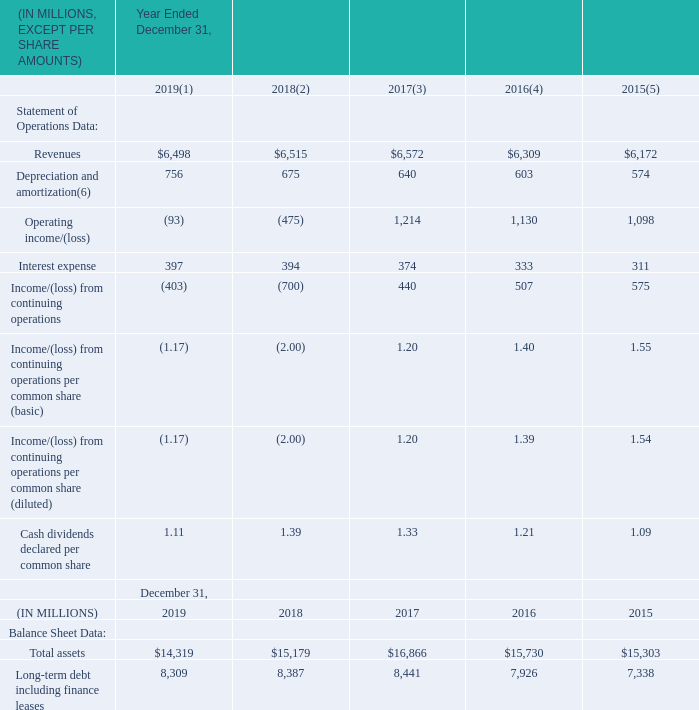Item 6. Selected Financial and Other Data
The following table sets forth selected historical consolidated financial data as of the dates and for the periods indicated. The selected consolidated statement of operations data for the years ended December 31, 2019, 2018 and 2017, and selected consolidated balance sheet data as of December 31, 2019 and 2018 have been derived from our audited consolidated financial statements and related notes appearing elsewhere in this Form 10-K. The selected consolidated statement of operations data for the years ended December 31, 2016 and 2015 and selected consolidated balance sheet data as of December 31, 2017, 2016 and 2015 have been derived from our audited consolidated financial statements, which are not included in this annual report on Form 10-K.
The results of operations for any period are not necessarily indicative of the results to be expected for any future period. The audited consolidated financial statements, from which the historical financial information for the periods set forth below have been derived, were prepared in accordance with U.S. generally accepted accounting principles (“GAAP”). The selected historical consolidated financial data set forth below should be read in conjunction with, and are qualified by reference to “Management’s Discussion and Analysis of Financial Condition and Results of Operations” and our audited consolidated financial statements and related notes thereto appearing elsewhere in this annual report on Form 10-K.
(1) Loss for the year ended December 31, 2019 included $1,004 million in impairment charges associated with our Connect reporting unit, a non-cash expense of $170 for the settlement of certain pension plans and $80 million in restructuring charges. See Item 7. “Management’s Discussion and Analysis of Financial Condition and Results of Operations—Goodwill and Indefinite-Lived Intangible Asset”. See Note 11 “Pensions and Other Post-Retirement Benefits” for further discussion on the pension settlement charge.
(2) Loss for the year ended December 31, 2018 included $1,411 million in impairment charges associated with our Connect reporting unit and $139 million in restructuring charges. See Item 7. “Management’s Discussion and Analysis of Financial Condition and Results of Operations—Goodwill and Indefinite- Lived Intangible Assets”.
(3) Income for the year ended December 31, 2017 included $80 million in restructuring charges.
(4) Income for the year ended December 31, 2016 included $105 million in restructuring charges.
(5) Income for the year ended December 31, 2015 included $51 million in restructuring charges, a gain of $158 million recorded from the step acquisition of Nielsen Catalina Solutions and an $8 million charge associated with the change to the Venezuelan currency exchange rate mechanism.
(6) Depreciation and amortization expense included charges for the depreciation and amortization of tangible and intangible assets acquired in business combinations of $205 million, $220 million, $219 million, $210 million and $205 million for the years ended December 31, 2019, 2018, 2017, 2016 and 2015, respectively.
What does the loss for the year ended December 31, 2019 include? $1,004 million in impairment charges associated with our connect reporting unit, a non-cash expense of $170 for the settlement of certain pension plans and $80 million in restructuring charges. What does the income for the year ended December 31, 2017 include? $80 million in restructuring charges. What is the amount of total assets in 2019?
Answer scale should be: million. 14,319. How many of the years have revenue above 6,500 million? 2018 ## 2017
Answer: 2. Which year has the highest amount of total assets? Look at row 15 , and COL3 to COL7 to find the year with the highest value
Answer: 2017. What is the percentage change in the operating loss from 2018 to 2019?
Answer scale should be: percent. (93-475)/475
Answer: -80.42. 